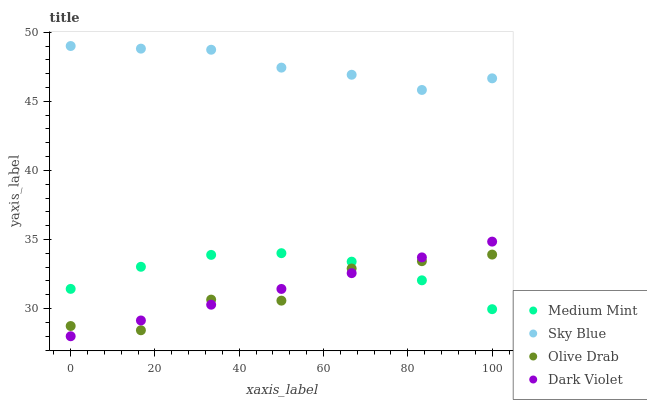Does Olive Drab have the minimum area under the curve?
Answer yes or no. Yes. Does Sky Blue have the maximum area under the curve?
Answer yes or no. Yes. Does Dark Violet have the minimum area under the curve?
Answer yes or no. No. Does Dark Violet have the maximum area under the curve?
Answer yes or no. No. Is Dark Violet the smoothest?
Answer yes or no. Yes. Is Olive Drab the roughest?
Answer yes or no. Yes. Is Sky Blue the smoothest?
Answer yes or no. No. Is Sky Blue the roughest?
Answer yes or no. No. Does Dark Violet have the lowest value?
Answer yes or no. Yes. Does Sky Blue have the lowest value?
Answer yes or no. No. Does Sky Blue have the highest value?
Answer yes or no. Yes. Does Dark Violet have the highest value?
Answer yes or no. No. Is Dark Violet less than Sky Blue?
Answer yes or no. Yes. Is Sky Blue greater than Dark Violet?
Answer yes or no. Yes. Does Medium Mint intersect Olive Drab?
Answer yes or no. Yes. Is Medium Mint less than Olive Drab?
Answer yes or no. No. Is Medium Mint greater than Olive Drab?
Answer yes or no. No. Does Dark Violet intersect Sky Blue?
Answer yes or no. No. 